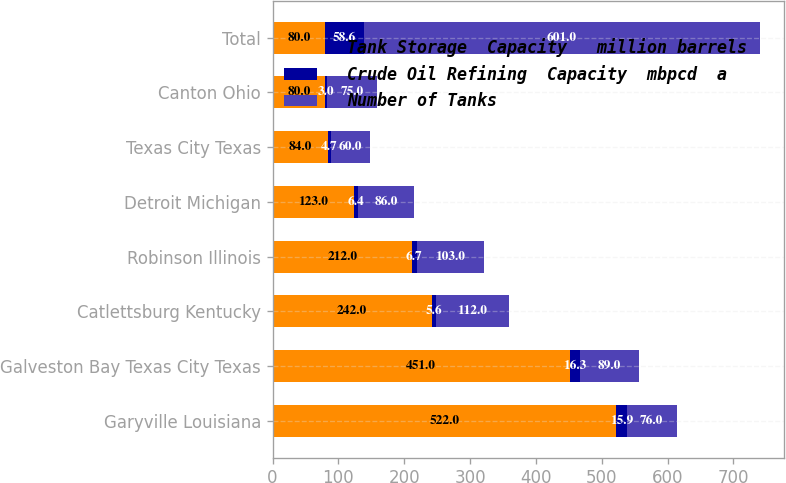<chart> <loc_0><loc_0><loc_500><loc_500><stacked_bar_chart><ecel><fcel>Garyville Louisiana<fcel>Galveston Bay Texas City Texas<fcel>Catlettsburg Kentucky<fcel>Robinson Illinois<fcel>Detroit Michigan<fcel>Texas City Texas<fcel>Canton Ohio<fcel>Total<nl><fcel>Tank Storage  Capacity   million barrels<fcel>522<fcel>451<fcel>242<fcel>212<fcel>123<fcel>84<fcel>80<fcel>80<nl><fcel>Crude Oil Refining  Capacity  mbpcd  a<fcel>15.9<fcel>16.3<fcel>5.6<fcel>6.7<fcel>6.4<fcel>4.7<fcel>3<fcel>58.6<nl><fcel>Number of Tanks<fcel>76<fcel>89<fcel>112<fcel>103<fcel>86<fcel>60<fcel>75<fcel>601<nl></chart> 